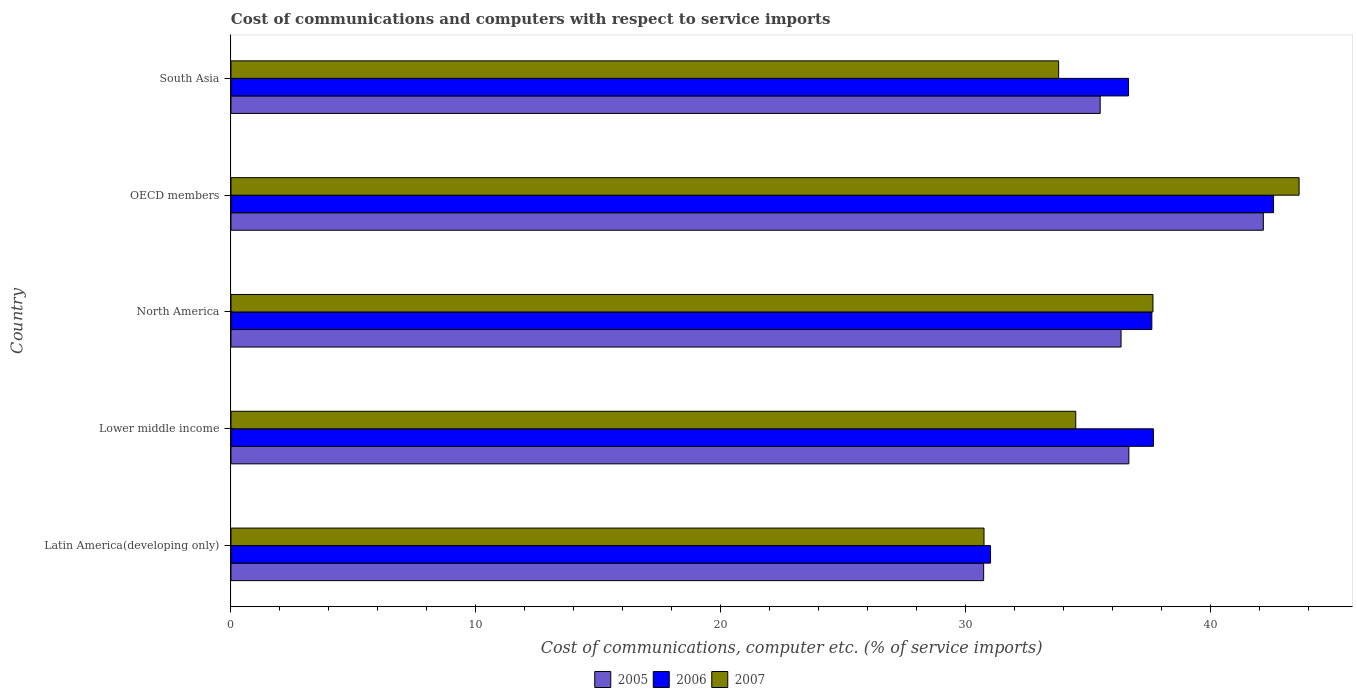How many different coloured bars are there?
Ensure brevity in your answer.  3. How many groups of bars are there?
Provide a succinct answer. 5. Are the number of bars on each tick of the Y-axis equal?
Give a very brief answer. Yes. In how many cases, is the number of bars for a given country not equal to the number of legend labels?
Offer a terse response. 0. What is the cost of communications and computers in 2007 in Lower middle income?
Keep it short and to the point. 34.5. Across all countries, what is the maximum cost of communications and computers in 2005?
Ensure brevity in your answer.  42.17. Across all countries, what is the minimum cost of communications and computers in 2005?
Give a very brief answer. 30.74. In which country was the cost of communications and computers in 2006 minimum?
Make the answer very short. Latin America(developing only). What is the total cost of communications and computers in 2005 in the graph?
Your answer should be compact. 181.44. What is the difference between the cost of communications and computers in 2007 in Latin America(developing only) and that in North America?
Ensure brevity in your answer.  -6.9. What is the difference between the cost of communications and computers in 2007 in South Asia and the cost of communications and computers in 2006 in OECD members?
Give a very brief answer. -8.78. What is the average cost of communications and computers in 2007 per country?
Your answer should be compact. 36.07. What is the difference between the cost of communications and computers in 2006 and cost of communications and computers in 2005 in OECD members?
Offer a terse response. 0.42. In how many countries, is the cost of communications and computers in 2007 greater than 34 %?
Your answer should be compact. 3. What is the ratio of the cost of communications and computers in 2007 in Latin America(developing only) to that in Lower middle income?
Keep it short and to the point. 0.89. Is the cost of communications and computers in 2006 in Lower middle income less than that in South Asia?
Your response must be concise. No. Is the difference between the cost of communications and computers in 2006 in Latin America(developing only) and North America greater than the difference between the cost of communications and computers in 2005 in Latin America(developing only) and North America?
Ensure brevity in your answer.  No. What is the difference between the highest and the second highest cost of communications and computers in 2005?
Offer a terse response. 5.49. What is the difference between the highest and the lowest cost of communications and computers in 2006?
Your answer should be compact. 11.56. In how many countries, is the cost of communications and computers in 2007 greater than the average cost of communications and computers in 2007 taken over all countries?
Provide a succinct answer. 2. Is it the case that in every country, the sum of the cost of communications and computers in 2006 and cost of communications and computers in 2005 is greater than the cost of communications and computers in 2007?
Keep it short and to the point. Yes. How many bars are there?
Your answer should be compact. 15. What is the difference between two consecutive major ticks on the X-axis?
Keep it short and to the point. 10. Are the values on the major ticks of X-axis written in scientific E-notation?
Give a very brief answer. No. Does the graph contain grids?
Provide a succinct answer. No. How many legend labels are there?
Give a very brief answer. 3. How are the legend labels stacked?
Your answer should be compact. Horizontal. What is the title of the graph?
Your answer should be very brief. Cost of communications and computers with respect to service imports. Does "1991" appear as one of the legend labels in the graph?
Your answer should be very brief. No. What is the label or title of the X-axis?
Provide a short and direct response. Cost of communications, computer etc. (% of service imports). What is the Cost of communications, computer etc. (% of service imports) in 2005 in Latin America(developing only)?
Offer a very short reply. 30.74. What is the Cost of communications, computer etc. (% of service imports) of 2006 in Latin America(developing only)?
Your response must be concise. 31.02. What is the Cost of communications, computer etc. (% of service imports) of 2007 in Latin America(developing only)?
Offer a terse response. 30.76. What is the Cost of communications, computer etc. (% of service imports) of 2005 in Lower middle income?
Offer a very short reply. 36.67. What is the Cost of communications, computer etc. (% of service imports) of 2006 in Lower middle income?
Keep it short and to the point. 37.67. What is the Cost of communications, computer etc. (% of service imports) of 2007 in Lower middle income?
Your answer should be compact. 34.5. What is the Cost of communications, computer etc. (% of service imports) in 2005 in North America?
Provide a short and direct response. 36.35. What is the Cost of communications, computer etc. (% of service imports) in 2006 in North America?
Make the answer very short. 37.61. What is the Cost of communications, computer etc. (% of service imports) in 2007 in North America?
Keep it short and to the point. 37.66. What is the Cost of communications, computer etc. (% of service imports) in 2005 in OECD members?
Provide a succinct answer. 42.17. What is the Cost of communications, computer etc. (% of service imports) of 2006 in OECD members?
Your answer should be very brief. 42.58. What is the Cost of communications, computer etc. (% of service imports) in 2007 in OECD members?
Keep it short and to the point. 43.63. What is the Cost of communications, computer etc. (% of service imports) of 2005 in South Asia?
Provide a succinct answer. 35.5. What is the Cost of communications, computer etc. (% of service imports) of 2006 in South Asia?
Offer a very short reply. 36.66. What is the Cost of communications, computer etc. (% of service imports) in 2007 in South Asia?
Ensure brevity in your answer.  33.8. Across all countries, what is the maximum Cost of communications, computer etc. (% of service imports) in 2005?
Offer a terse response. 42.17. Across all countries, what is the maximum Cost of communications, computer etc. (% of service imports) in 2006?
Ensure brevity in your answer.  42.58. Across all countries, what is the maximum Cost of communications, computer etc. (% of service imports) in 2007?
Ensure brevity in your answer.  43.63. Across all countries, what is the minimum Cost of communications, computer etc. (% of service imports) in 2005?
Your answer should be very brief. 30.74. Across all countries, what is the minimum Cost of communications, computer etc. (% of service imports) of 2006?
Give a very brief answer. 31.02. Across all countries, what is the minimum Cost of communications, computer etc. (% of service imports) of 2007?
Offer a terse response. 30.76. What is the total Cost of communications, computer etc. (% of service imports) in 2005 in the graph?
Your answer should be very brief. 181.44. What is the total Cost of communications, computer etc. (% of service imports) of 2006 in the graph?
Your answer should be compact. 185.55. What is the total Cost of communications, computer etc. (% of service imports) in 2007 in the graph?
Make the answer very short. 180.35. What is the difference between the Cost of communications, computer etc. (% of service imports) of 2005 in Latin America(developing only) and that in Lower middle income?
Provide a succinct answer. -5.93. What is the difference between the Cost of communications, computer etc. (% of service imports) in 2006 in Latin America(developing only) and that in Lower middle income?
Ensure brevity in your answer.  -6.65. What is the difference between the Cost of communications, computer etc. (% of service imports) of 2007 in Latin America(developing only) and that in Lower middle income?
Give a very brief answer. -3.75. What is the difference between the Cost of communications, computer etc. (% of service imports) in 2005 in Latin America(developing only) and that in North America?
Offer a very short reply. -5.61. What is the difference between the Cost of communications, computer etc. (% of service imports) of 2006 in Latin America(developing only) and that in North America?
Ensure brevity in your answer.  -6.59. What is the difference between the Cost of communications, computer etc. (% of service imports) in 2007 in Latin America(developing only) and that in North America?
Keep it short and to the point. -6.9. What is the difference between the Cost of communications, computer etc. (% of service imports) in 2005 in Latin America(developing only) and that in OECD members?
Offer a terse response. -11.42. What is the difference between the Cost of communications, computer etc. (% of service imports) in 2006 in Latin America(developing only) and that in OECD members?
Ensure brevity in your answer.  -11.56. What is the difference between the Cost of communications, computer etc. (% of service imports) of 2007 in Latin America(developing only) and that in OECD members?
Your response must be concise. -12.87. What is the difference between the Cost of communications, computer etc. (% of service imports) in 2005 in Latin America(developing only) and that in South Asia?
Offer a terse response. -4.76. What is the difference between the Cost of communications, computer etc. (% of service imports) in 2006 in Latin America(developing only) and that in South Asia?
Offer a terse response. -5.64. What is the difference between the Cost of communications, computer etc. (% of service imports) of 2007 in Latin America(developing only) and that in South Asia?
Offer a terse response. -3.05. What is the difference between the Cost of communications, computer etc. (% of service imports) of 2005 in Lower middle income and that in North America?
Provide a succinct answer. 0.32. What is the difference between the Cost of communications, computer etc. (% of service imports) of 2006 in Lower middle income and that in North America?
Give a very brief answer. 0.06. What is the difference between the Cost of communications, computer etc. (% of service imports) in 2007 in Lower middle income and that in North America?
Provide a succinct answer. -3.15. What is the difference between the Cost of communications, computer etc. (% of service imports) in 2005 in Lower middle income and that in OECD members?
Provide a short and direct response. -5.49. What is the difference between the Cost of communications, computer etc. (% of service imports) in 2006 in Lower middle income and that in OECD members?
Provide a succinct answer. -4.91. What is the difference between the Cost of communications, computer etc. (% of service imports) of 2007 in Lower middle income and that in OECD members?
Your response must be concise. -9.12. What is the difference between the Cost of communications, computer etc. (% of service imports) of 2005 in Lower middle income and that in South Asia?
Provide a succinct answer. 1.17. What is the difference between the Cost of communications, computer etc. (% of service imports) of 2006 in Lower middle income and that in South Asia?
Ensure brevity in your answer.  1.02. What is the difference between the Cost of communications, computer etc. (% of service imports) in 2007 in Lower middle income and that in South Asia?
Provide a short and direct response. 0.7. What is the difference between the Cost of communications, computer etc. (% of service imports) in 2005 in North America and that in OECD members?
Provide a short and direct response. -5.81. What is the difference between the Cost of communications, computer etc. (% of service imports) of 2006 in North America and that in OECD members?
Provide a succinct answer. -4.97. What is the difference between the Cost of communications, computer etc. (% of service imports) of 2007 in North America and that in OECD members?
Give a very brief answer. -5.97. What is the difference between the Cost of communications, computer etc. (% of service imports) in 2005 in North America and that in South Asia?
Keep it short and to the point. 0.85. What is the difference between the Cost of communications, computer etc. (% of service imports) of 2006 in North America and that in South Asia?
Ensure brevity in your answer.  0.95. What is the difference between the Cost of communications, computer etc. (% of service imports) of 2007 in North America and that in South Asia?
Your answer should be compact. 3.85. What is the difference between the Cost of communications, computer etc. (% of service imports) in 2005 in OECD members and that in South Asia?
Your answer should be very brief. 6.66. What is the difference between the Cost of communications, computer etc. (% of service imports) in 2006 in OECD members and that in South Asia?
Ensure brevity in your answer.  5.92. What is the difference between the Cost of communications, computer etc. (% of service imports) of 2007 in OECD members and that in South Asia?
Offer a very short reply. 9.82. What is the difference between the Cost of communications, computer etc. (% of service imports) of 2005 in Latin America(developing only) and the Cost of communications, computer etc. (% of service imports) of 2006 in Lower middle income?
Ensure brevity in your answer.  -6.93. What is the difference between the Cost of communications, computer etc. (% of service imports) in 2005 in Latin America(developing only) and the Cost of communications, computer etc. (% of service imports) in 2007 in Lower middle income?
Your answer should be very brief. -3.76. What is the difference between the Cost of communications, computer etc. (% of service imports) in 2006 in Latin America(developing only) and the Cost of communications, computer etc. (% of service imports) in 2007 in Lower middle income?
Make the answer very short. -3.48. What is the difference between the Cost of communications, computer etc. (% of service imports) in 2005 in Latin America(developing only) and the Cost of communications, computer etc. (% of service imports) in 2006 in North America?
Keep it short and to the point. -6.87. What is the difference between the Cost of communications, computer etc. (% of service imports) of 2005 in Latin America(developing only) and the Cost of communications, computer etc. (% of service imports) of 2007 in North America?
Your answer should be very brief. -6.92. What is the difference between the Cost of communications, computer etc. (% of service imports) of 2006 in Latin America(developing only) and the Cost of communications, computer etc. (% of service imports) of 2007 in North America?
Your answer should be very brief. -6.63. What is the difference between the Cost of communications, computer etc. (% of service imports) in 2005 in Latin America(developing only) and the Cost of communications, computer etc. (% of service imports) in 2006 in OECD members?
Your answer should be very brief. -11.84. What is the difference between the Cost of communications, computer etc. (% of service imports) of 2005 in Latin America(developing only) and the Cost of communications, computer etc. (% of service imports) of 2007 in OECD members?
Your response must be concise. -12.88. What is the difference between the Cost of communications, computer etc. (% of service imports) of 2006 in Latin America(developing only) and the Cost of communications, computer etc. (% of service imports) of 2007 in OECD members?
Provide a short and direct response. -12.6. What is the difference between the Cost of communications, computer etc. (% of service imports) in 2005 in Latin America(developing only) and the Cost of communications, computer etc. (% of service imports) in 2006 in South Asia?
Make the answer very short. -5.92. What is the difference between the Cost of communications, computer etc. (% of service imports) in 2005 in Latin America(developing only) and the Cost of communications, computer etc. (% of service imports) in 2007 in South Asia?
Your answer should be very brief. -3.06. What is the difference between the Cost of communications, computer etc. (% of service imports) in 2006 in Latin America(developing only) and the Cost of communications, computer etc. (% of service imports) in 2007 in South Asia?
Provide a succinct answer. -2.78. What is the difference between the Cost of communications, computer etc. (% of service imports) of 2005 in Lower middle income and the Cost of communications, computer etc. (% of service imports) of 2006 in North America?
Your answer should be compact. -0.94. What is the difference between the Cost of communications, computer etc. (% of service imports) of 2005 in Lower middle income and the Cost of communications, computer etc. (% of service imports) of 2007 in North America?
Make the answer very short. -0.99. What is the difference between the Cost of communications, computer etc. (% of service imports) of 2006 in Lower middle income and the Cost of communications, computer etc. (% of service imports) of 2007 in North America?
Provide a succinct answer. 0.02. What is the difference between the Cost of communications, computer etc. (% of service imports) of 2005 in Lower middle income and the Cost of communications, computer etc. (% of service imports) of 2006 in OECD members?
Provide a short and direct response. -5.91. What is the difference between the Cost of communications, computer etc. (% of service imports) in 2005 in Lower middle income and the Cost of communications, computer etc. (% of service imports) in 2007 in OECD members?
Keep it short and to the point. -6.95. What is the difference between the Cost of communications, computer etc. (% of service imports) in 2006 in Lower middle income and the Cost of communications, computer etc. (% of service imports) in 2007 in OECD members?
Keep it short and to the point. -5.95. What is the difference between the Cost of communications, computer etc. (% of service imports) of 2005 in Lower middle income and the Cost of communications, computer etc. (% of service imports) of 2006 in South Asia?
Your answer should be compact. 0.01. What is the difference between the Cost of communications, computer etc. (% of service imports) of 2005 in Lower middle income and the Cost of communications, computer etc. (% of service imports) of 2007 in South Asia?
Your answer should be compact. 2.87. What is the difference between the Cost of communications, computer etc. (% of service imports) in 2006 in Lower middle income and the Cost of communications, computer etc. (% of service imports) in 2007 in South Asia?
Provide a succinct answer. 3.87. What is the difference between the Cost of communications, computer etc. (% of service imports) in 2005 in North America and the Cost of communications, computer etc. (% of service imports) in 2006 in OECD members?
Keep it short and to the point. -6.23. What is the difference between the Cost of communications, computer etc. (% of service imports) in 2005 in North America and the Cost of communications, computer etc. (% of service imports) in 2007 in OECD members?
Give a very brief answer. -7.27. What is the difference between the Cost of communications, computer etc. (% of service imports) in 2006 in North America and the Cost of communications, computer etc. (% of service imports) in 2007 in OECD members?
Make the answer very short. -6.01. What is the difference between the Cost of communications, computer etc. (% of service imports) of 2005 in North America and the Cost of communications, computer etc. (% of service imports) of 2006 in South Asia?
Keep it short and to the point. -0.31. What is the difference between the Cost of communications, computer etc. (% of service imports) of 2005 in North America and the Cost of communications, computer etc. (% of service imports) of 2007 in South Asia?
Offer a very short reply. 2.55. What is the difference between the Cost of communications, computer etc. (% of service imports) in 2006 in North America and the Cost of communications, computer etc. (% of service imports) in 2007 in South Asia?
Give a very brief answer. 3.81. What is the difference between the Cost of communications, computer etc. (% of service imports) of 2005 in OECD members and the Cost of communications, computer etc. (% of service imports) of 2006 in South Asia?
Your answer should be very brief. 5.51. What is the difference between the Cost of communications, computer etc. (% of service imports) of 2005 in OECD members and the Cost of communications, computer etc. (% of service imports) of 2007 in South Asia?
Ensure brevity in your answer.  8.36. What is the difference between the Cost of communications, computer etc. (% of service imports) of 2006 in OECD members and the Cost of communications, computer etc. (% of service imports) of 2007 in South Asia?
Your answer should be compact. 8.78. What is the average Cost of communications, computer etc. (% of service imports) in 2005 per country?
Ensure brevity in your answer.  36.29. What is the average Cost of communications, computer etc. (% of service imports) of 2006 per country?
Your answer should be very brief. 37.11. What is the average Cost of communications, computer etc. (% of service imports) in 2007 per country?
Your response must be concise. 36.07. What is the difference between the Cost of communications, computer etc. (% of service imports) in 2005 and Cost of communications, computer etc. (% of service imports) in 2006 in Latin America(developing only)?
Offer a terse response. -0.28. What is the difference between the Cost of communications, computer etc. (% of service imports) of 2005 and Cost of communications, computer etc. (% of service imports) of 2007 in Latin America(developing only)?
Your response must be concise. -0.01. What is the difference between the Cost of communications, computer etc. (% of service imports) in 2006 and Cost of communications, computer etc. (% of service imports) in 2007 in Latin America(developing only)?
Your answer should be very brief. 0.27. What is the difference between the Cost of communications, computer etc. (% of service imports) in 2005 and Cost of communications, computer etc. (% of service imports) in 2006 in Lower middle income?
Your answer should be compact. -1. What is the difference between the Cost of communications, computer etc. (% of service imports) of 2005 and Cost of communications, computer etc. (% of service imports) of 2007 in Lower middle income?
Offer a terse response. 2.17. What is the difference between the Cost of communications, computer etc. (% of service imports) in 2006 and Cost of communications, computer etc. (% of service imports) in 2007 in Lower middle income?
Your answer should be compact. 3.17. What is the difference between the Cost of communications, computer etc. (% of service imports) of 2005 and Cost of communications, computer etc. (% of service imports) of 2006 in North America?
Your answer should be very brief. -1.26. What is the difference between the Cost of communications, computer etc. (% of service imports) in 2005 and Cost of communications, computer etc. (% of service imports) in 2007 in North America?
Offer a terse response. -1.3. What is the difference between the Cost of communications, computer etc. (% of service imports) of 2006 and Cost of communications, computer etc. (% of service imports) of 2007 in North America?
Your answer should be very brief. -0.05. What is the difference between the Cost of communications, computer etc. (% of service imports) of 2005 and Cost of communications, computer etc. (% of service imports) of 2006 in OECD members?
Your answer should be very brief. -0.42. What is the difference between the Cost of communications, computer etc. (% of service imports) of 2005 and Cost of communications, computer etc. (% of service imports) of 2007 in OECD members?
Ensure brevity in your answer.  -1.46. What is the difference between the Cost of communications, computer etc. (% of service imports) in 2006 and Cost of communications, computer etc. (% of service imports) in 2007 in OECD members?
Provide a short and direct response. -1.04. What is the difference between the Cost of communications, computer etc. (% of service imports) in 2005 and Cost of communications, computer etc. (% of service imports) in 2006 in South Asia?
Offer a terse response. -1.16. What is the difference between the Cost of communications, computer etc. (% of service imports) in 2005 and Cost of communications, computer etc. (% of service imports) in 2007 in South Asia?
Ensure brevity in your answer.  1.7. What is the difference between the Cost of communications, computer etc. (% of service imports) of 2006 and Cost of communications, computer etc. (% of service imports) of 2007 in South Asia?
Ensure brevity in your answer.  2.86. What is the ratio of the Cost of communications, computer etc. (% of service imports) in 2005 in Latin America(developing only) to that in Lower middle income?
Offer a very short reply. 0.84. What is the ratio of the Cost of communications, computer etc. (% of service imports) in 2006 in Latin America(developing only) to that in Lower middle income?
Ensure brevity in your answer.  0.82. What is the ratio of the Cost of communications, computer etc. (% of service imports) in 2007 in Latin America(developing only) to that in Lower middle income?
Offer a very short reply. 0.89. What is the ratio of the Cost of communications, computer etc. (% of service imports) in 2005 in Latin America(developing only) to that in North America?
Make the answer very short. 0.85. What is the ratio of the Cost of communications, computer etc. (% of service imports) of 2006 in Latin America(developing only) to that in North America?
Ensure brevity in your answer.  0.82. What is the ratio of the Cost of communications, computer etc. (% of service imports) in 2007 in Latin America(developing only) to that in North America?
Offer a very short reply. 0.82. What is the ratio of the Cost of communications, computer etc. (% of service imports) in 2005 in Latin America(developing only) to that in OECD members?
Give a very brief answer. 0.73. What is the ratio of the Cost of communications, computer etc. (% of service imports) of 2006 in Latin America(developing only) to that in OECD members?
Offer a very short reply. 0.73. What is the ratio of the Cost of communications, computer etc. (% of service imports) in 2007 in Latin America(developing only) to that in OECD members?
Provide a short and direct response. 0.7. What is the ratio of the Cost of communications, computer etc. (% of service imports) of 2005 in Latin America(developing only) to that in South Asia?
Keep it short and to the point. 0.87. What is the ratio of the Cost of communications, computer etc. (% of service imports) in 2006 in Latin America(developing only) to that in South Asia?
Your answer should be compact. 0.85. What is the ratio of the Cost of communications, computer etc. (% of service imports) in 2007 in Latin America(developing only) to that in South Asia?
Provide a short and direct response. 0.91. What is the ratio of the Cost of communications, computer etc. (% of service imports) of 2005 in Lower middle income to that in North America?
Your answer should be compact. 1.01. What is the ratio of the Cost of communications, computer etc. (% of service imports) of 2006 in Lower middle income to that in North America?
Your answer should be compact. 1. What is the ratio of the Cost of communications, computer etc. (% of service imports) in 2007 in Lower middle income to that in North America?
Your response must be concise. 0.92. What is the ratio of the Cost of communications, computer etc. (% of service imports) in 2005 in Lower middle income to that in OECD members?
Give a very brief answer. 0.87. What is the ratio of the Cost of communications, computer etc. (% of service imports) in 2006 in Lower middle income to that in OECD members?
Provide a succinct answer. 0.88. What is the ratio of the Cost of communications, computer etc. (% of service imports) of 2007 in Lower middle income to that in OECD members?
Your answer should be very brief. 0.79. What is the ratio of the Cost of communications, computer etc. (% of service imports) in 2005 in Lower middle income to that in South Asia?
Keep it short and to the point. 1.03. What is the ratio of the Cost of communications, computer etc. (% of service imports) in 2006 in Lower middle income to that in South Asia?
Provide a short and direct response. 1.03. What is the ratio of the Cost of communications, computer etc. (% of service imports) in 2007 in Lower middle income to that in South Asia?
Your response must be concise. 1.02. What is the ratio of the Cost of communications, computer etc. (% of service imports) of 2005 in North America to that in OECD members?
Make the answer very short. 0.86. What is the ratio of the Cost of communications, computer etc. (% of service imports) of 2006 in North America to that in OECD members?
Make the answer very short. 0.88. What is the ratio of the Cost of communications, computer etc. (% of service imports) in 2007 in North America to that in OECD members?
Keep it short and to the point. 0.86. What is the ratio of the Cost of communications, computer etc. (% of service imports) in 2007 in North America to that in South Asia?
Keep it short and to the point. 1.11. What is the ratio of the Cost of communications, computer etc. (% of service imports) of 2005 in OECD members to that in South Asia?
Offer a terse response. 1.19. What is the ratio of the Cost of communications, computer etc. (% of service imports) of 2006 in OECD members to that in South Asia?
Provide a succinct answer. 1.16. What is the ratio of the Cost of communications, computer etc. (% of service imports) of 2007 in OECD members to that in South Asia?
Your response must be concise. 1.29. What is the difference between the highest and the second highest Cost of communications, computer etc. (% of service imports) in 2005?
Provide a succinct answer. 5.49. What is the difference between the highest and the second highest Cost of communications, computer etc. (% of service imports) of 2006?
Your response must be concise. 4.91. What is the difference between the highest and the second highest Cost of communications, computer etc. (% of service imports) of 2007?
Provide a succinct answer. 5.97. What is the difference between the highest and the lowest Cost of communications, computer etc. (% of service imports) in 2005?
Ensure brevity in your answer.  11.42. What is the difference between the highest and the lowest Cost of communications, computer etc. (% of service imports) of 2006?
Ensure brevity in your answer.  11.56. What is the difference between the highest and the lowest Cost of communications, computer etc. (% of service imports) of 2007?
Offer a very short reply. 12.87. 